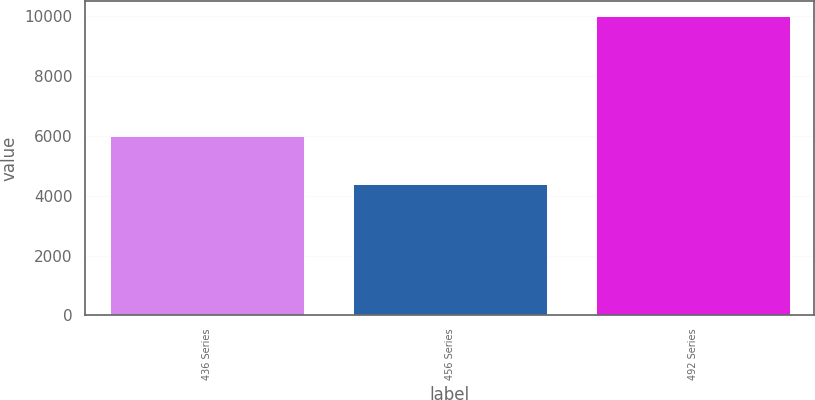Convert chart to OTSL. <chart><loc_0><loc_0><loc_500><loc_500><bar_chart><fcel>436 Series<fcel>456 Series<fcel>492 Series<nl><fcel>5992<fcel>4389<fcel>10000<nl></chart> 